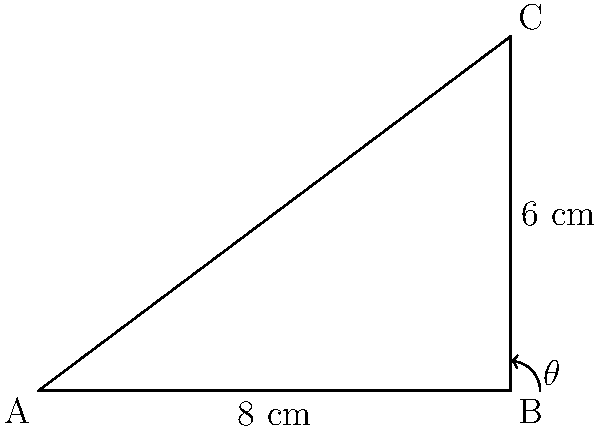You're designing a custom closet organizer and need to determine the optimal angle for a slanted shelf. The closet has a depth of 8 cm and a height of 6 cm. What angle $\theta$ should the shelf be placed at to maximize storage space while ensuring items don't slide off easily? To find the optimal angle for the shelf, we need to calculate the angle of the triangle formed by the closet dimensions. Let's approach this step-by-step:

1. We have a right triangle with the following dimensions:
   - Base (depth of closet) = 8 cm
   - Height = 6 cm
   - Hypotenuse = diagonal of the closet (to be calculated)

2. To find the angle $\theta$, we can use the arctangent function:

   $\theta = \arctan(\frac{\text{opposite}}{\text{adjacent}})$

3. In this case:
   - Opposite = Height = 6 cm
   - Adjacent = Base = 8 cm

4. Plugging these values into the formula:

   $\theta = \arctan(\frac{6}{8})$

5. Calculating this:

   $\theta = \arctan(0.75) \approx 36.87°$

6. For optimal shelf placement, we want the angle to be slightly less than this to prevent items from sliding off easily. A good rule of thumb is to subtract about 5-10 degrees.

7. Therefore, the optimal angle for the shelf would be approximately 30°.

This angle provides a good balance between maximizing storage space and ensuring items remain secure on the shelf.
Answer: 30° 